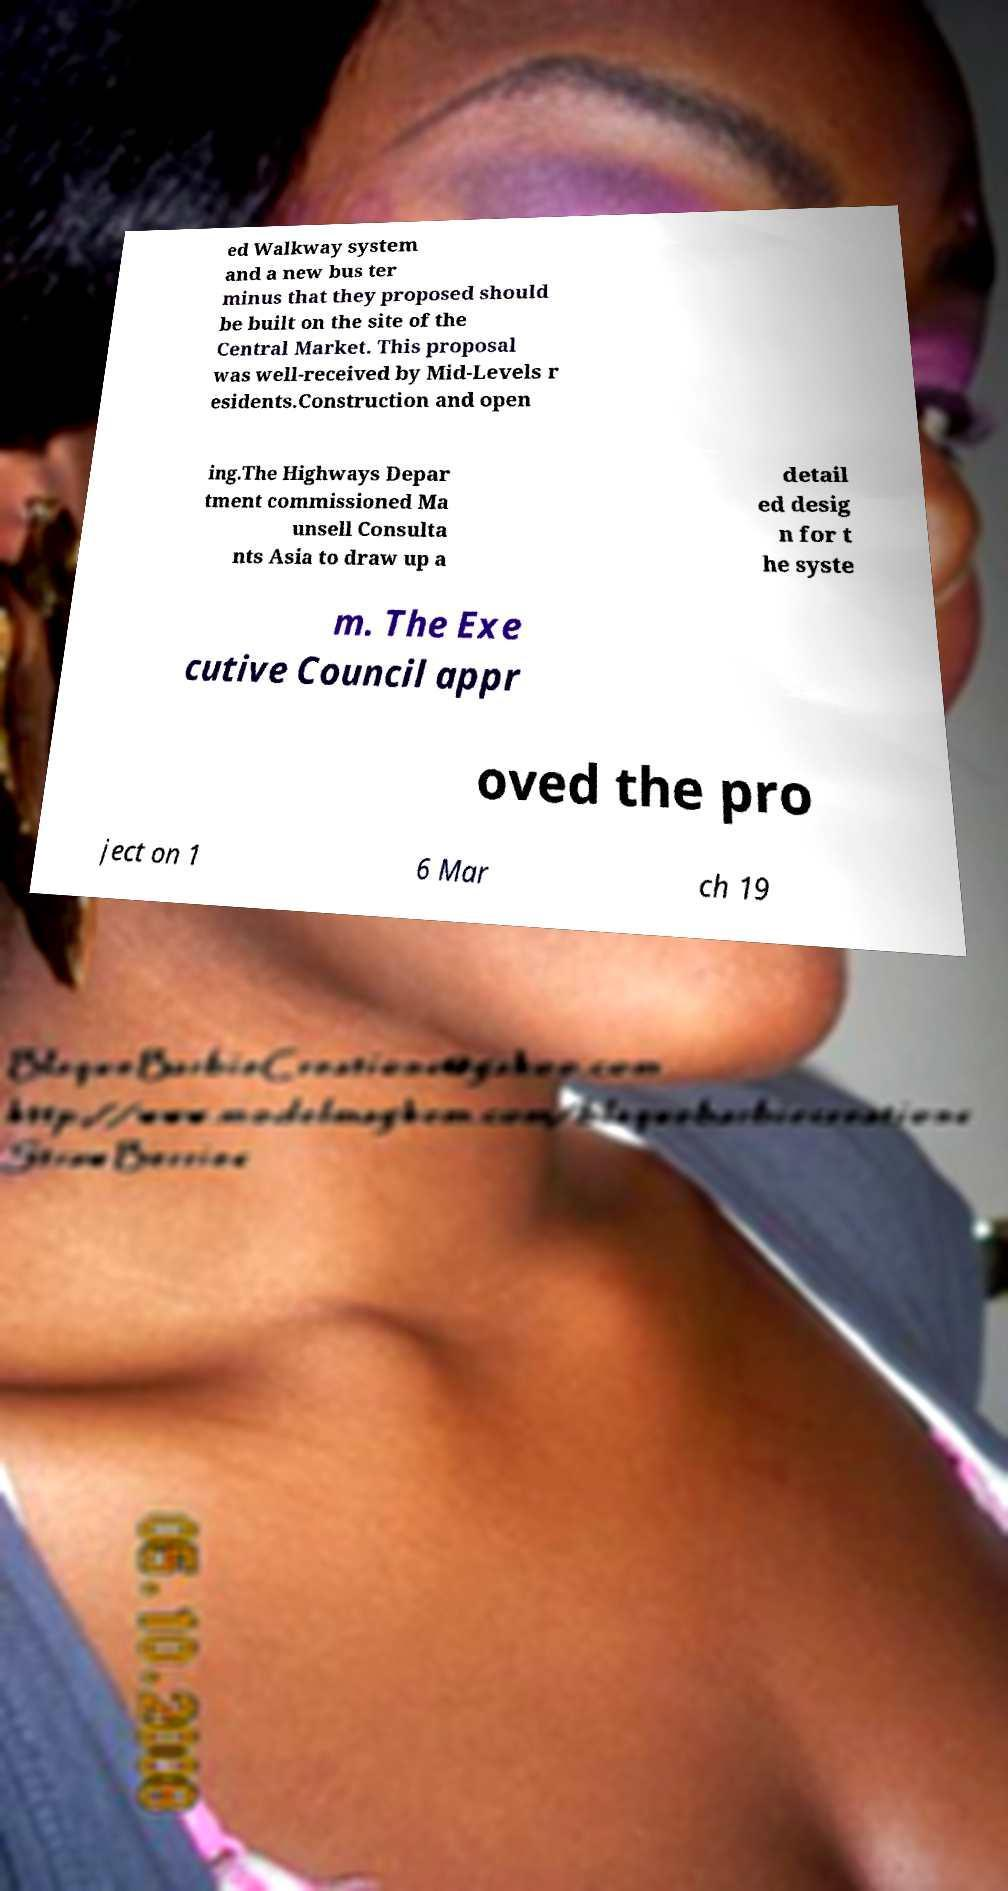Please read and relay the text visible in this image. What does it say? ed Walkway system and a new bus ter minus that they proposed should be built on the site of the Central Market. This proposal was well-received by Mid-Levels r esidents.Construction and open ing.The Highways Depar tment commissioned Ma unsell Consulta nts Asia to draw up a detail ed desig n for t he syste m. The Exe cutive Council appr oved the pro ject on 1 6 Mar ch 19 